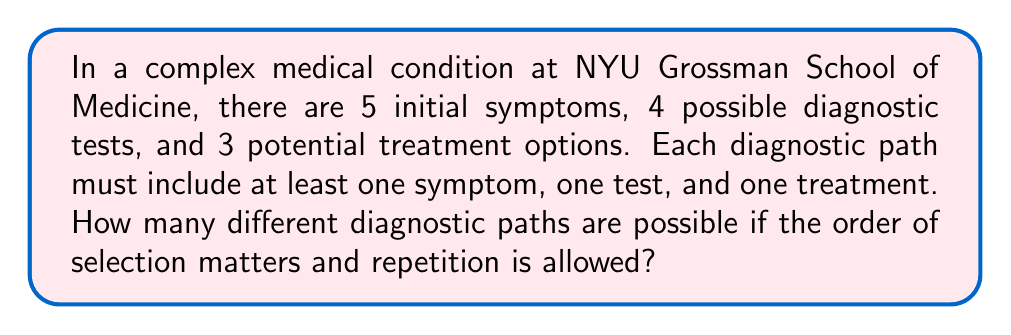Can you answer this question? Let's approach this step-by-step:

1) We need to calculate the number of ways to select at least one item from each category (symptoms, tests, treatments) where order matters and repetition is allowed.

2) For each category, we can select any number of items from 1 to all of them. This is equivalent to selecting items with repetition allowed, but excluding the empty set.

3) For symptoms:
   - Total ways = $5^1 + 5^2 + 5^3 + 5^4 + 5^5 = \sum_{i=1}^5 5^i$
   - This can be calculated using the formula for geometric series:
     $$S = \frac{a(1-r^n)}{1-r} = \frac{5(1-5^5)}{1-5} = 3905$$

4) Similarly for tests:
   $\sum_{i=1}^4 4^i = 340$

5) And for treatments:
   $\sum_{i=1}^3 3^i = 39$

6) Now, for each diagnostic path, we need to choose at least one from each category. By the multiplication principle, the total number of paths is:

   $$3905 \times 340 \times 39 = 51,831,300$$

Therefore, there are 51,831,300 different possible diagnostic paths.
Answer: 51,831,300 